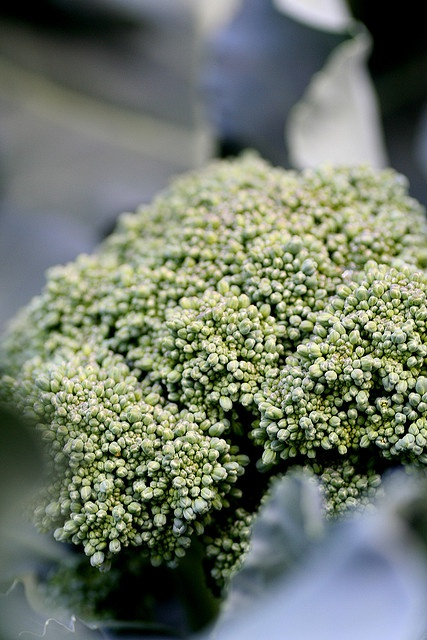Describe the objects in this image and their specific colors. I can see a broccoli in black, darkgray, olive, and beige tones in this image. 